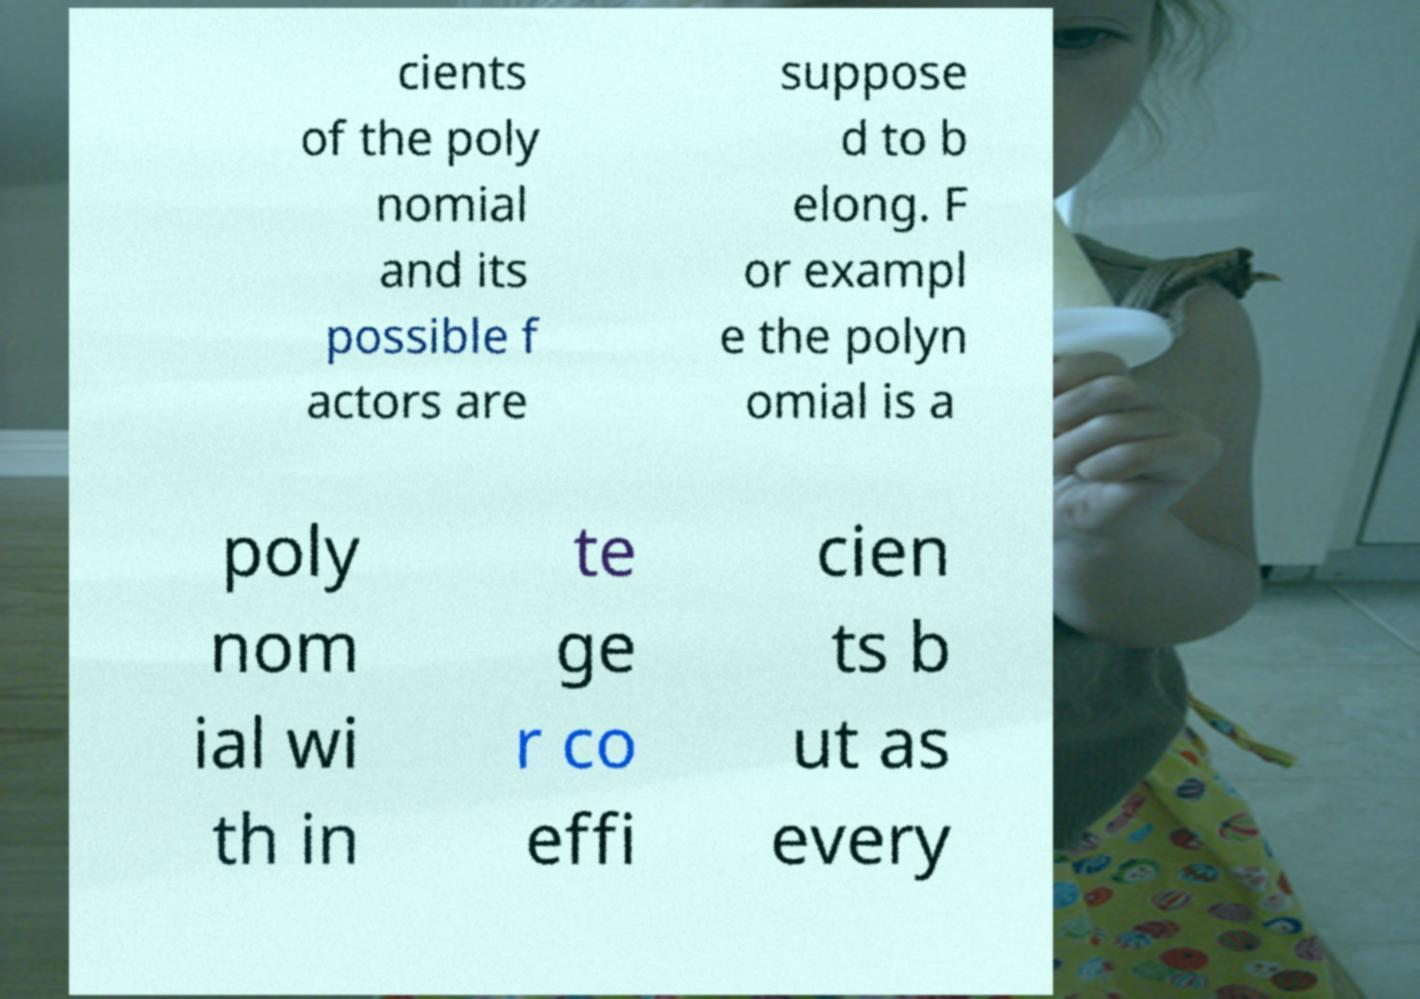I need the written content from this picture converted into text. Can you do that? cients of the poly nomial and its possible f actors are suppose d to b elong. F or exampl e the polyn omial is a poly nom ial wi th in te ge r co effi cien ts b ut as every 